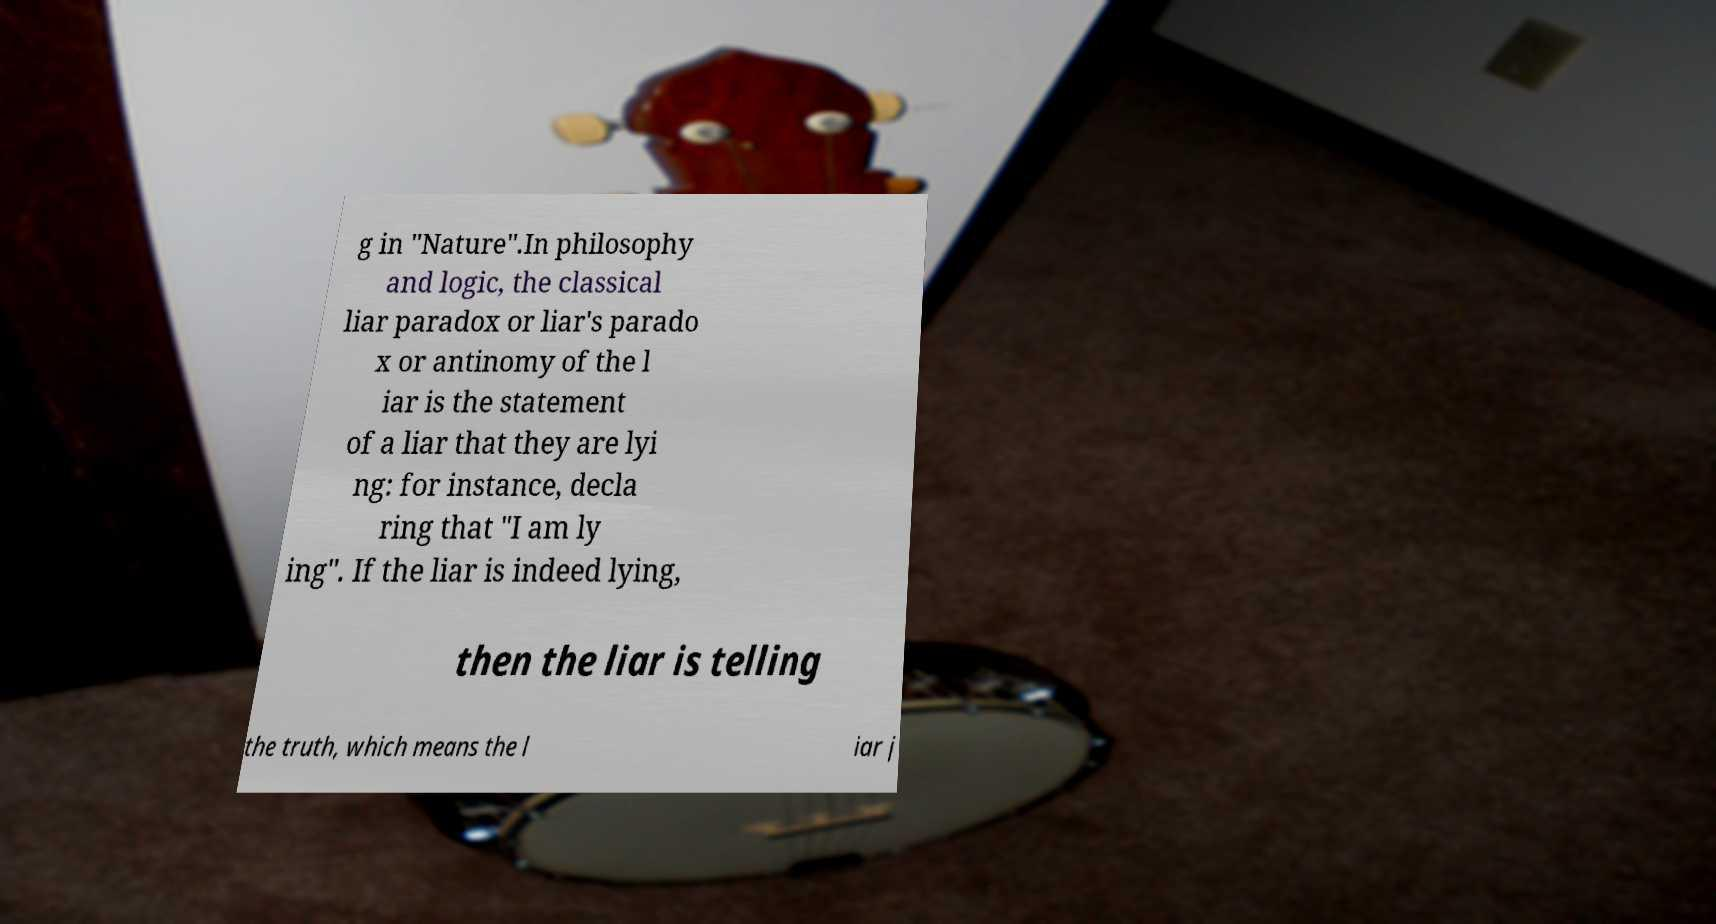Could you extract and type out the text from this image? g in "Nature".In philosophy and logic, the classical liar paradox or liar's parado x or antinomy of the l iar is the statement of a liar that they are lyi ng: for instance, decla ring that "I am ly ing". If the liar is indeed lying, then the liar is telling the truth, which means the l iar j 